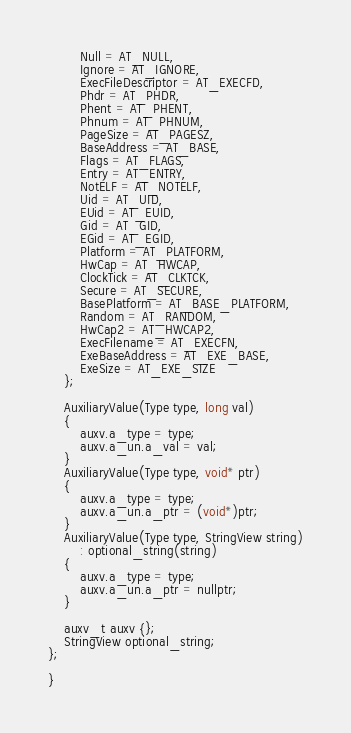Convert code to text. <code><loc_0><loc_0><loc_500><loc_500><_C_>        Null = AT_NULL,
        Ignore = AT_IGNORE,
        ExecFileDescriptor = AT_EXECFD,
        Phdr = AT_PHDR,
        Phent = AT_PHENT,
        Phnum = AT_PHNUM,
        PageSize = AT_PAGESZ,
        BaseAddress = AT_BASE,
        Flags = AT_FLAGS,
        Entry = AT_ENTRY,
        NotELF = AT_NOTELF,
        Uid = AT_UID,
        EUid = AT_EUID,
        Gid = AT_GID,
        EGid = AT_EGID,
        Platform = AT_PLATFORM,
        HwCap = AT_HWCAP,
        ClockTick = AT_CLKTCK,
        Secure = AT_SECURE,
        BasePlatform = AT_BASE_PLATFORM,
        Random = AT_RANDOM,
        HwCap2 = AT_HWCAP2,
        ExecFilename = AT_EXECFN,
        ExeBaseAddress = AT_EXE_BASE,
        ExeSize = AT_EXE_SIZE
    };

    AuxiliaryValue(Type type, long val)
    {
        auxv.a_type = type;
        auxv.a_un.a_val = val;
    }
    AuxiliaryValue(Type type, void* ptr)
    {
        auxv.a_type = type;
        auxv.a_un.a_ptr = (void*)ptr;
    }
    AuxiliaryValue(Type type, StringView string)
        : optional_string(string)
    {
        auxv.a_type = type;
        auxv.a_un.a_ptr = nullptr;
    }

    auxv_t auxv {};
    StringView optional_string;
};

}
</code> 